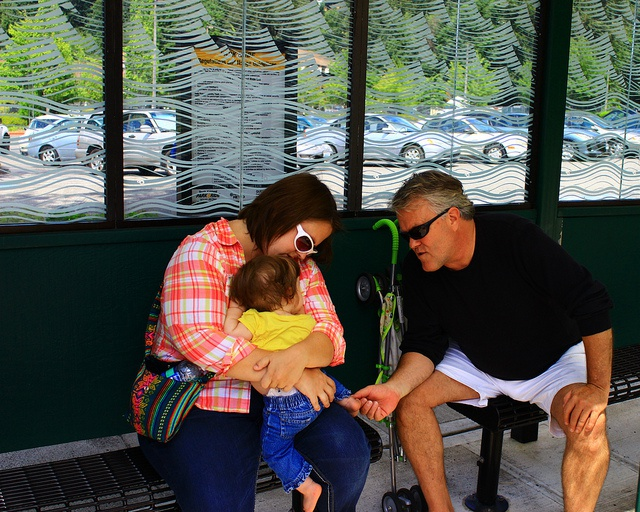Describe the objects in this image and their specific colors. I can see chair in black, gray, and blue tones, people in black, tan, salmon, and maroon tones, people in black, brown, tan, and maroon tones, people in black, navy, maroon, and gold tones, and bench in black, gray, and blue tones in this image. 